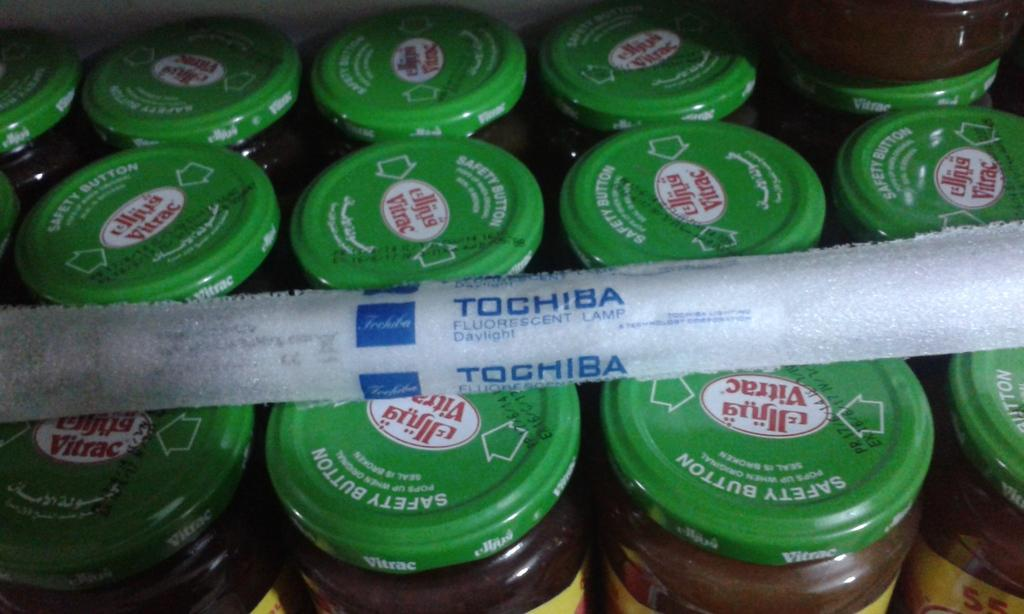<image>
Create a compact narrative representing the image presented. Jars with safety buttons have a strip of plastic over them with a Toshiba logo. 